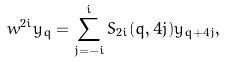Convert formula to latex. <formula><loc_0><loc_0><loc_500><loc_500>w ^ { 2 i } y _ { q } = \sum ^ { i } _ { j = - i } S _ { 2 i } ( q , 4 j ) y _ { q + 4 j } ,</formula> 